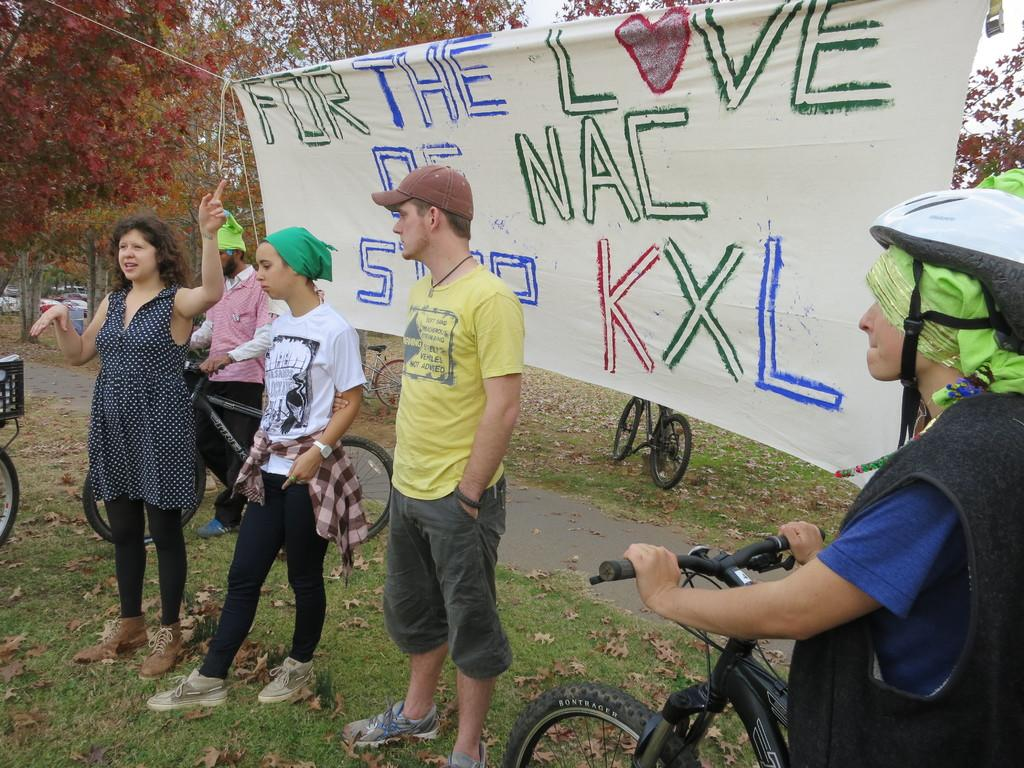What are the persons in the image doing? The persons in the image are standing and walking, holding bicycles and a banner. Where is the scene taking place? The scene takes place in a park. What can be seen in the background of the image? There are trees in the background of the image. What is the level of anger among the persons in the image? There is no indication of anger among the persons in the image; they are simply holding bicycles and a banner. What is the desire of the persons in the image? There is no information about the desires of the persons in the image; they are simply standing, walking, and holding bicycles and a banner. 